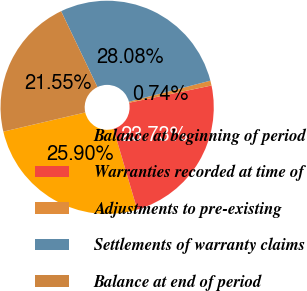Convert chart. <chart><loc_0><loc_0><loc_500><loc_500><pie_chart><fcel>Balance at beginning of period<fcel>Warranties recorded at time of<fcel>Adjustments to pre-existing<fcel>Settlements of warranty claims<fcel>Balance at end of period<nl><fcel>25.9%<fcel>23.73%<fcel>0.74%<fcel>28.08%<fcel>21.55%<nl></chart> 